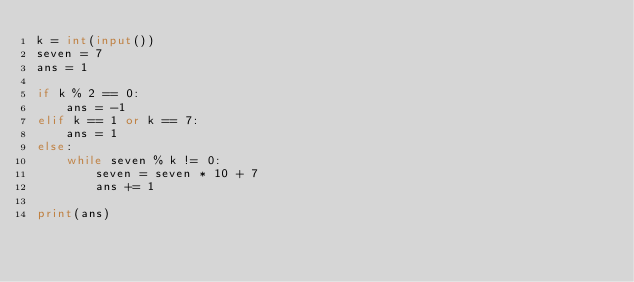Convert code to text. <code><loc_0><loc_0><loc_500><loc_500><_Python_>k = int(input())
seven = 7
ans = 1

if k % 2 == 0:
    ans = -1
elif k == 1 or k == 7:
    ans = 1
else:
    while seven % k != 0:
        seven = seven * 10 + 7
        ans += 1

print(ans)
</code> 